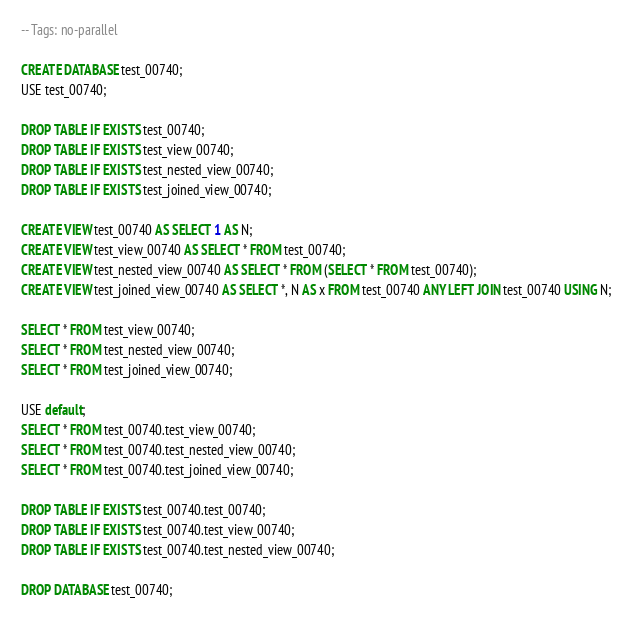Convert code to text. <code><loc_0><loc_0><loc_500><loc_500><_SQL_>-- Tags: no-parallel

CREATE DATABASE test_00740;
USE test_00740;

DROP TABLE IF EXISTS test_00740;
DROP TABLE IF EXISTS test_view_00740;
DROP TABLE IF EXISTS test_nested_view_00740;
DROP TABLE IF EXISTS test_joined_view_00740;

CREATE VIEW test_00740 AS SELECT 1 AS N;
CREATE VIEW test_view_00740 AS SELECT * FROM test_00740;
CREATE VIEW test_nested_view_00740 AS SELECT * FROM (SELECT * FROM test_00740);
CREATE VIEW test_joined_view_00740 AS SELECT *, N AS x FROM test_00740 ANY LEFT JOIN test_00740 USING N;

SELECT * FROM test_view_00740;
SELECT * FROM test_nested_view_00740;
SELECT * FROM test_joined_view_00740;

USE default;
SELECT * FROM test_00740.test_view_00740;
SELECT * FROM test_00740.test_nested_view_00740;
SELECT * FROM test_00740.test_joined_view_00740;

DROP TABLE IF EXISTS test_00740.test_00740;
DROP TABLE IF EXISTS test_00740.test_view_00740;
DROP TABLE IF EXISTS test_00740.test_nested_view_00740;

DROP DATABASE test_00740;
</code> 